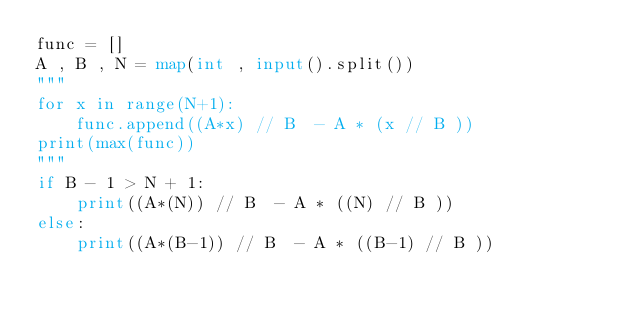Convert code to text. <code><loc_0><loc_0><loc_500><loc_500><_Python_>func = []
A , B , N = map(int , input().split())
"""
for x in range(N+1):
    func.append((A*x) // B  - A * (x // B ))
print(max(func))
"""
if B - 1 > N + 1:
    print((A*(N)) // B  - A * ((N) // B ))
else:
    print((A*(B-1)) // B  - A * ((B-1) // B ))</code> 